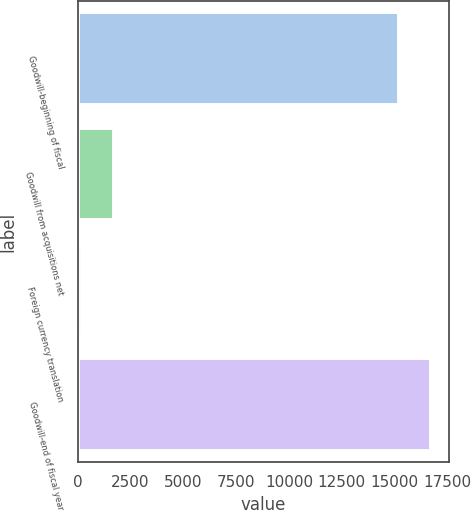Convert chart to OTSL. <chart><loc_0><loc_0><loc_500><loc_500><bar_chart><fcel>Goodwill-beginning of fiscal<fcel>Goodwill from acquisitions net<fcel>Foreign currency translation<fcel>Goodwill-end of fiscal year<nl><fcel>15194<fcel>1728.5<fcel>181<fcel>16741.5<nl></chart> 